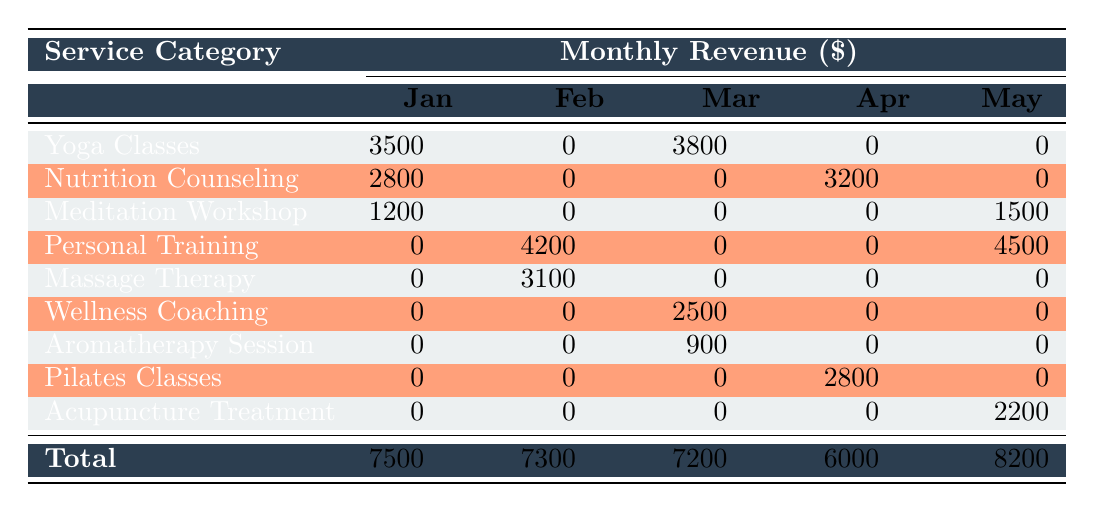What was the total revenue for Yoga Classes in January? In January, the revenue for Yoga Classes is listed as 3500. Since there’s only one entry for this service in January, the total revenue is directly that amount.
Answer: 3500 In which month did Personal Training generate the highest revenue? Personal Training had two entries: 4200 in February and 4500 in May. Comparing these values, 4500 in May is greater, indicating that May is the month with the highest revenue for this service.
Answer: May What is the total revenue for all services in March? To find the total revenue for March, sum the revenues from all the services listed in that month: 3800 (Yoga Classes) + 2500 (Wellness Coaching) + 900 (Aromatherapy Session) = 7200.
Answer: 7200 Did Nutrition Counseling generate any revenue in February? By checking the table, Nutrition Counseling shows 0 revenue in February, as per the respective entry. Therefore, it did not generate any revenue in that month.
Answer: No What was the average revenue for services in April? The services recorded in April and their revenues are Nutrition Counseling (3200), Pilates Classes (2800), and no other services. Adding those gives 3200 + 2800 = 6000. Since there are 2 entries, the average is 6000/2 = 3000.
Answer: 3000 Which instructor had the highest total revenue across all months listed? Calculate the total revenue for each instructor: Sarah Johnson (3500 + 3800 = 7300), Dr. Michael Lee (2800 + 3200 = 6000), Emma Thompson (1200 + 1500 = 2700), John Martinez (4200 + 4500 = 8700), Lisa Chen (3100), Amanda Foster (2500), Robert Chang (900), Emily Rodriguez (2800), Dr. Wei Zhang (2200). John Martinez has the highest total revenue at 8700.
Answer: John Martinez What service category generated revenue in both January and May? From the table, Nutrition Counseling is the only service with revenue generated in January (2800) but not in May (0), while Meditation Workshop generated 1200 in January and 1500 in May. Therefore, the correct answer point to Meditation Workshop as the service that generated revenue in both months.
Answer: Meditation Workshop Did any services generate cumulative revenue of at least 10,000 across the five months? By adding the total revenues for each service category through all months, we can determine if any sums exceed 10,000: - Yoga Classes: 3500 + 3800 = 7300 (not 10,000) - Nutrition Counseling: 2800 + 3200 = 6000 (not 10,000) - Meditation Workshop: 1200 + 1500 = 2700 (not 10,000) - Personal Training: 4200 + 4500 = 8700 (not 10,000) - Massage Therapy: 3100 (single entry) - Wellness Coaching: 2500 (single entry) - Aromatherapy Session: 900 (single entry) - Pilates Classes: 2800 (single entry) - Acupuncture Treatment: 2200 (single entry) None of these cumulative totals exceed 10,000.
Answer: No 